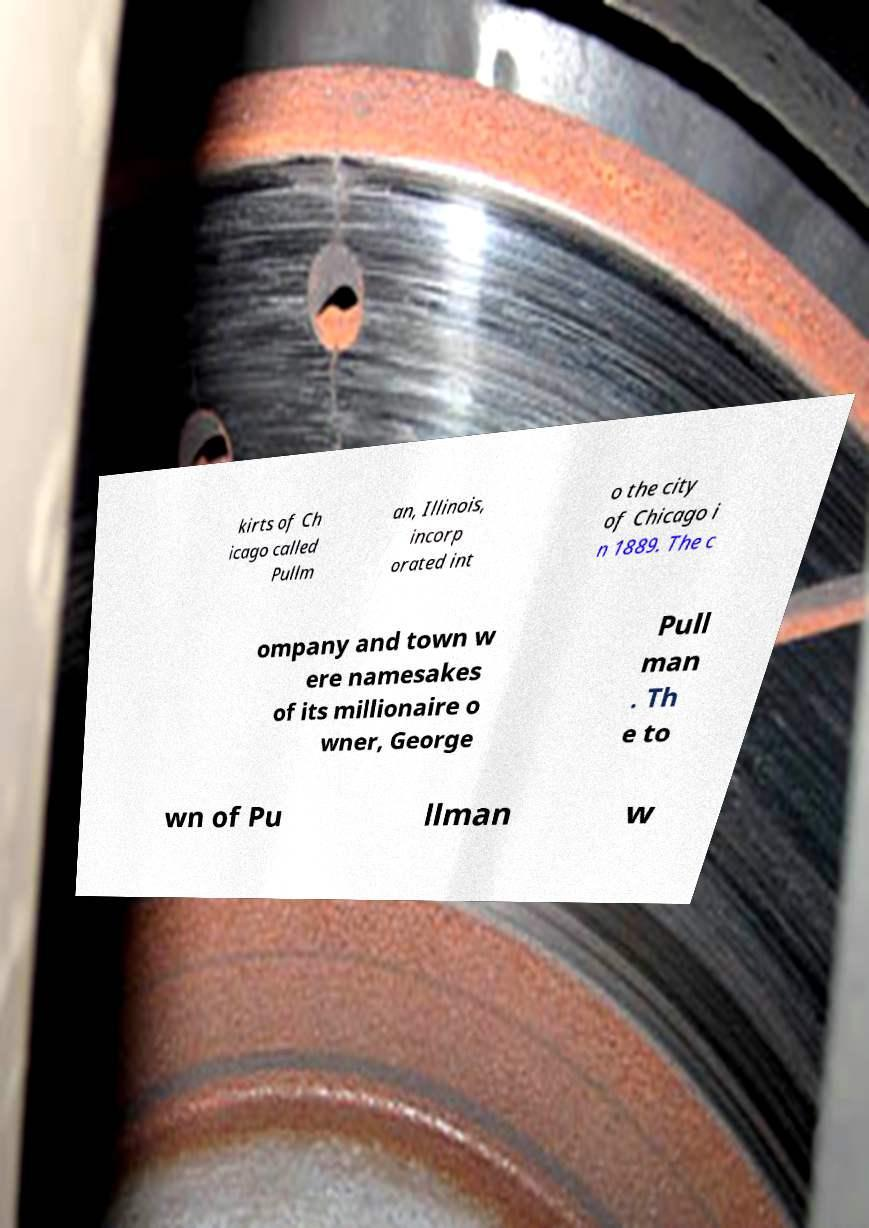Could you extract and type out the text from this image? kirts of Ch icago called Pullm an, Illinois, incorp orated int o the city of Chicago i n 1889. The c ompany and town w ere namesakes of its millionaire o wner, George Pull man . Th e to wn of Pu llman w 